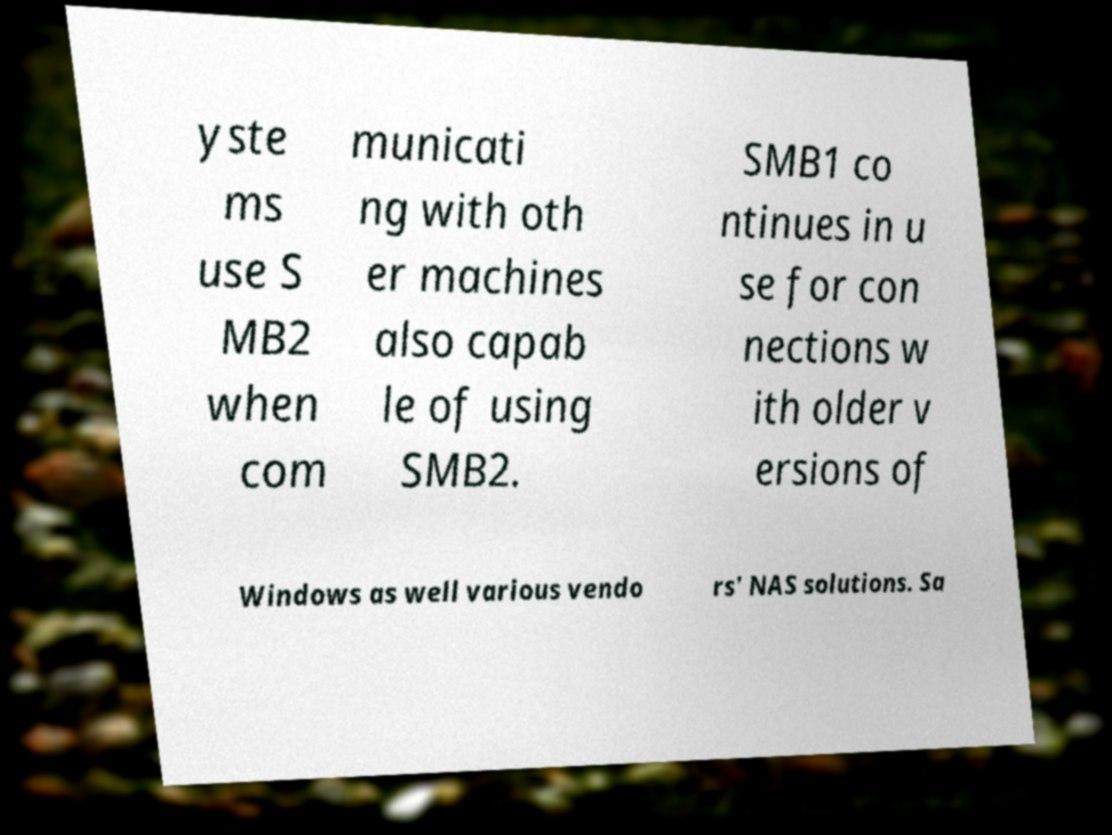For documentation purposes, I need the text within this image transcribed. Could you provide that? yste ms use S MB2 when com municati ng with oth er machines also capab le of using SMB2. SMB1 co ntinues in u se for con nections w ith older v ersions of Windows as well various vendo rs' NAS solutions. Sa 